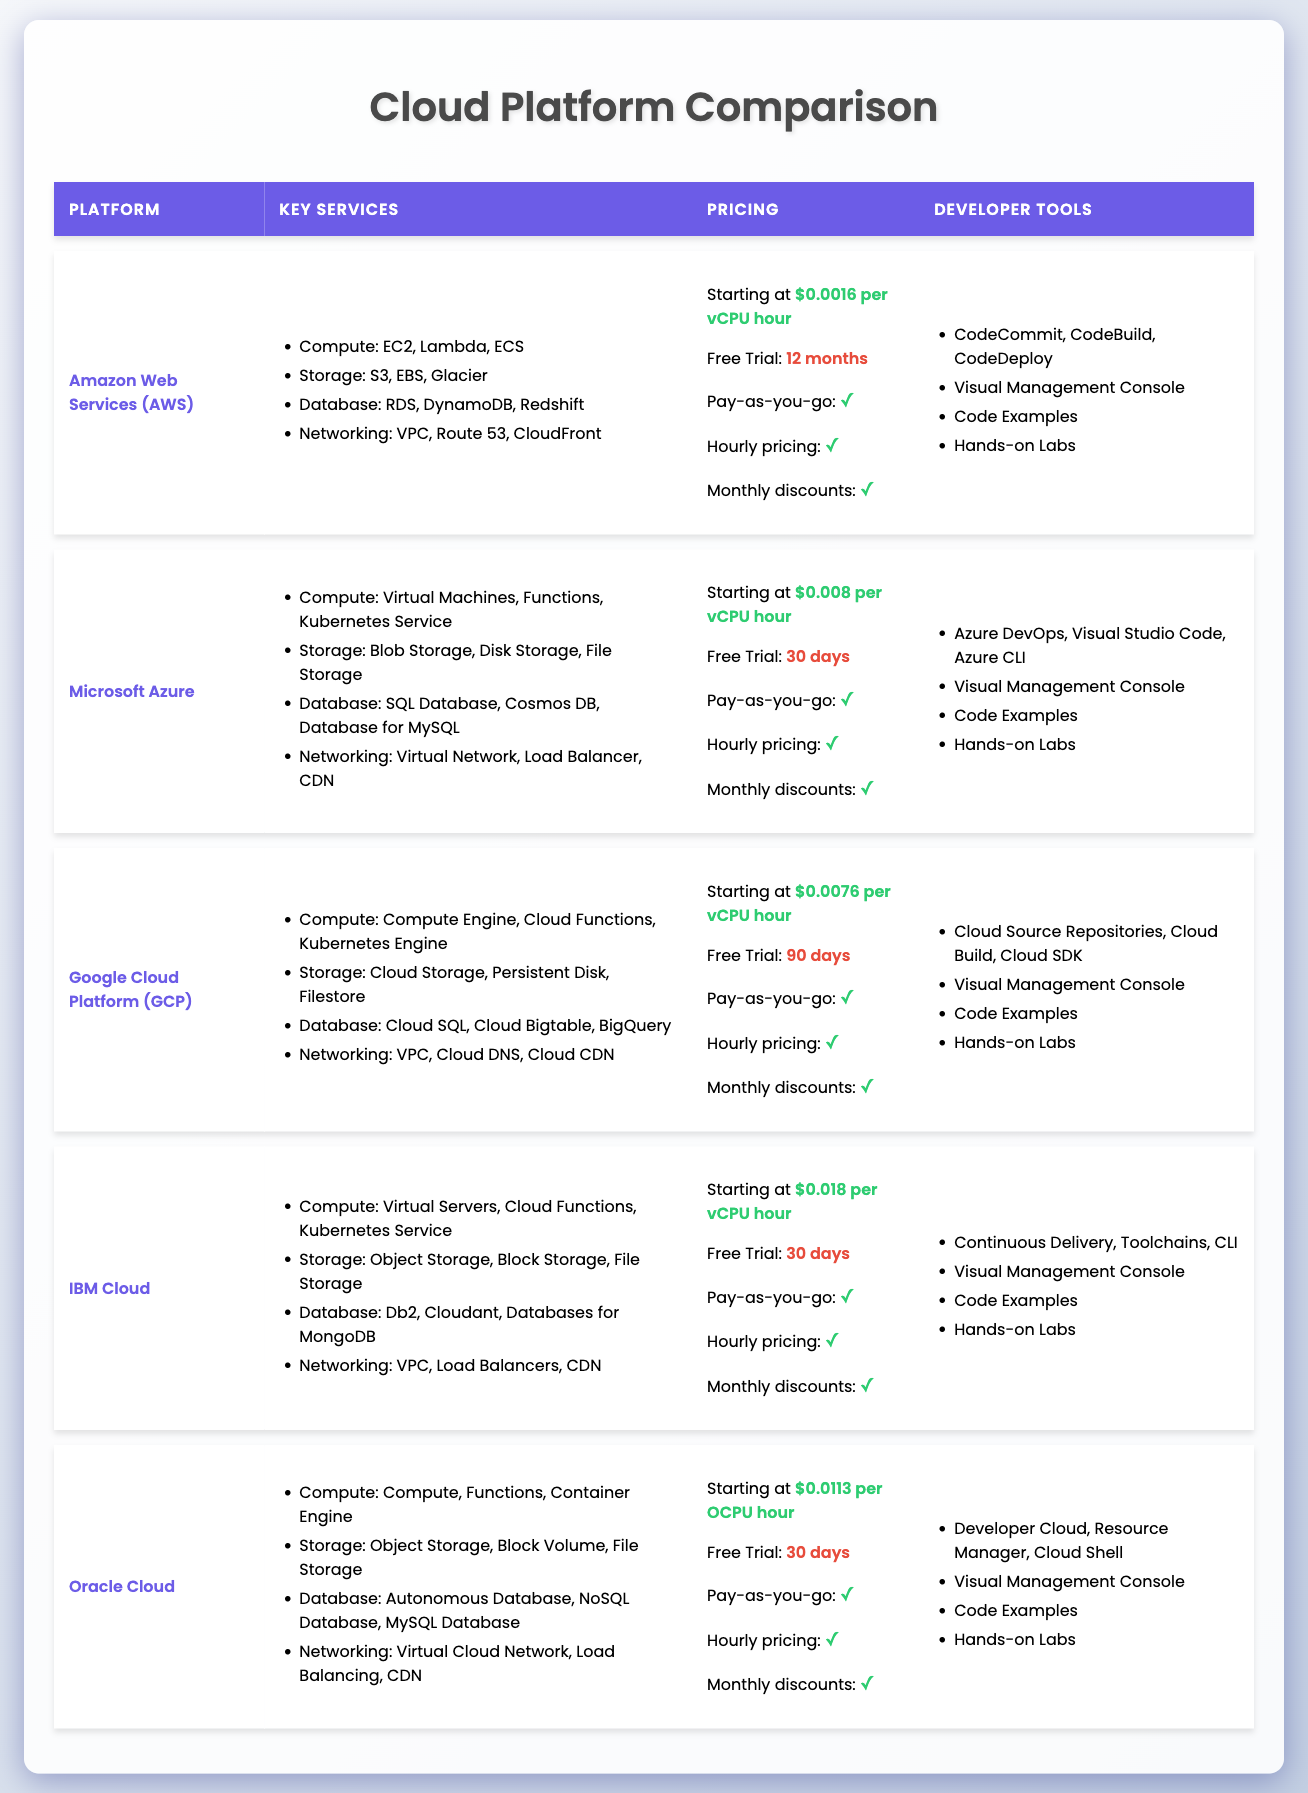What is the free trial period for Amazon Web Services (AWS)? The free trial period for AWS is specified in the table as "12 months," which is directly mentioned under the relevant column for AWS.
Answer: 12 months What is the starting price for Microsoft Azure? The table provides "Starting at $0.008 per vCPU hour" under the Microsoft Azure row, indicating the pricing information directly.
Answer: $0.008 per vCPU hour Which platforms offer a free trial of more than 30 days? The platforms with free trial periods longer than 30 days are Amazon Web Services (12 months) and Google Cloud Platform (90 days). Microsoft Azure, IBM Cloud, and Oracle Cloud all have a 30-day trial.
Answer: AWS and GCP Is the hourly pricing available for Google Cloud Platform (GCP)? The table indicates that hourly pricing is available for GCP, as indicated by the check icon (✓) in the relevant column.
Answer: Yes What is the average starting price per vCPU hour for the five platforms (excluding Oracle Cloud)? The starting prices for AWS, Microsoft Azure, Google Cloud Platform, and IBM Cloud are $0.0016, $0.008, $0.0076, and $0.018 respectively. Therefore, the average is calculated as follows: (0.0016 + 0.008 + 0.0076 + 0.018) / 4 = 0.0086, which translates to $0.0086 per vCPU hour.
Answer: $0.0086 per vCPU hour How many platforms provide a Visual Management Console? The table shows that all platforms listed—AWS, Microsoft Azure, Google Cloud Platform, IBM Cloud, and Oracle Cloud—provide a Visual Management Console, as indicated by the corresponding check icons (✓).
Answer: 5 Which cloud platform has the highest starting price per vCPU hour? By comparing the starting prices listed in the table, IBM Cloud has the highest starting price at $0.018 per vCPU hour compared to other platforms.
Answer: IBM Cloud Do Oracle Cloud and IBM Cloud offer hands-on labs? Checking the developer tools section for both platforms reveals that both Oracle Cloud and IBM Cloud have "Hands-on Labs," indicated by check icons.
Answer: Yes 